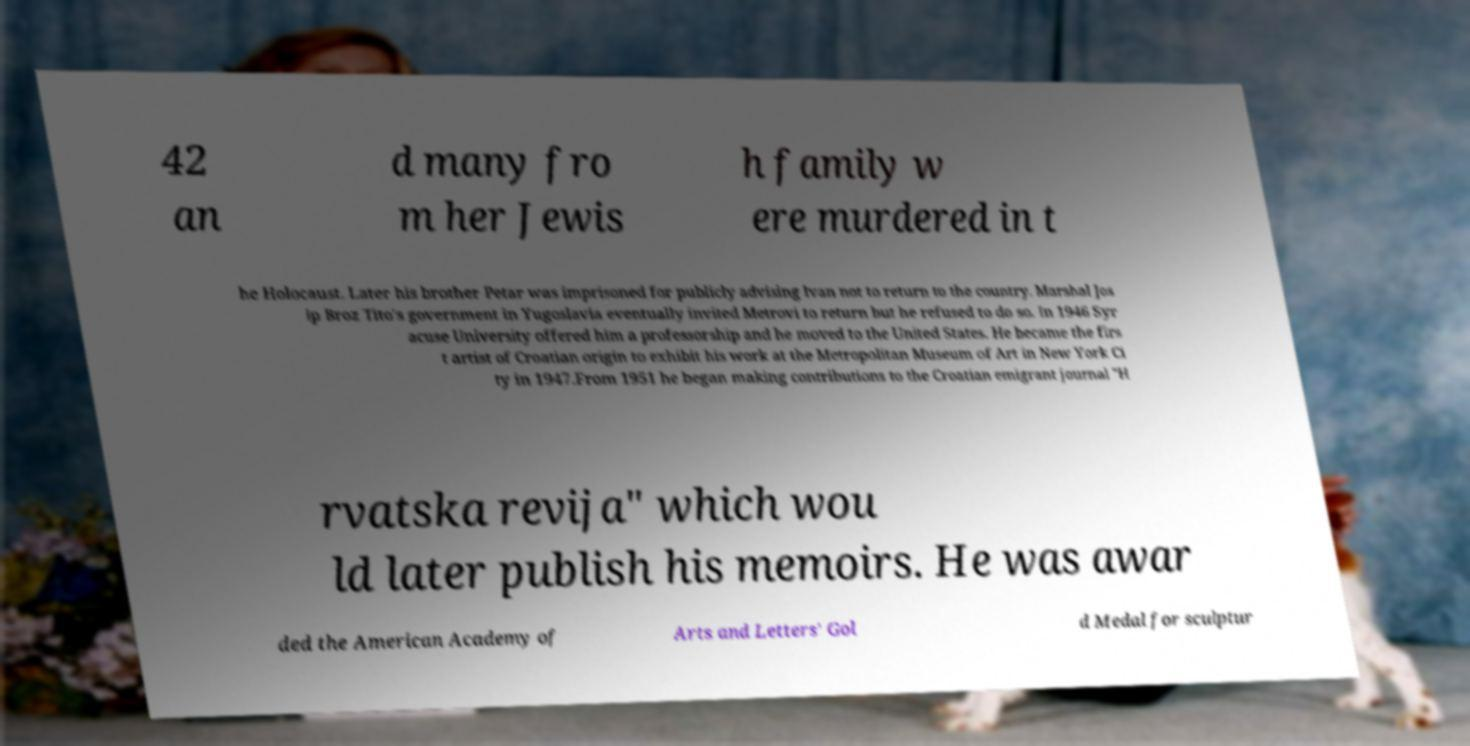Could you extract and type out the text from this image? 42 an d many fro m her Jewis h family w ere murdered in t he Holocaust. Later his brother Petar was imprisoned for publicly advising Ivan not to return to the country. Marshal Jos ip Broz Tito's government in Yugoslavia eventually invited Metrovi to return but he refused to do so. In 1946 Syr acuse University offered him a professorship and he moved to the United States. He became the firs t artist of Croatian origin to exhibit his work at the Metropolitan Museum of Art in New York Ci ty in 1947.From 1951 he began making contributions to the Croatian emigrant journal "H rvatska revija" which wou ld later publish his memoirs. He was awar ded the American Academy of Arts and Letters' Gol d Medal for sculptur 